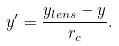<formula> <loc_0><loc_0><loc_500><loc_500>y ^ { \prime } = \frac { y _ { l e n s } - y } { r _ { c } } .</formula> 